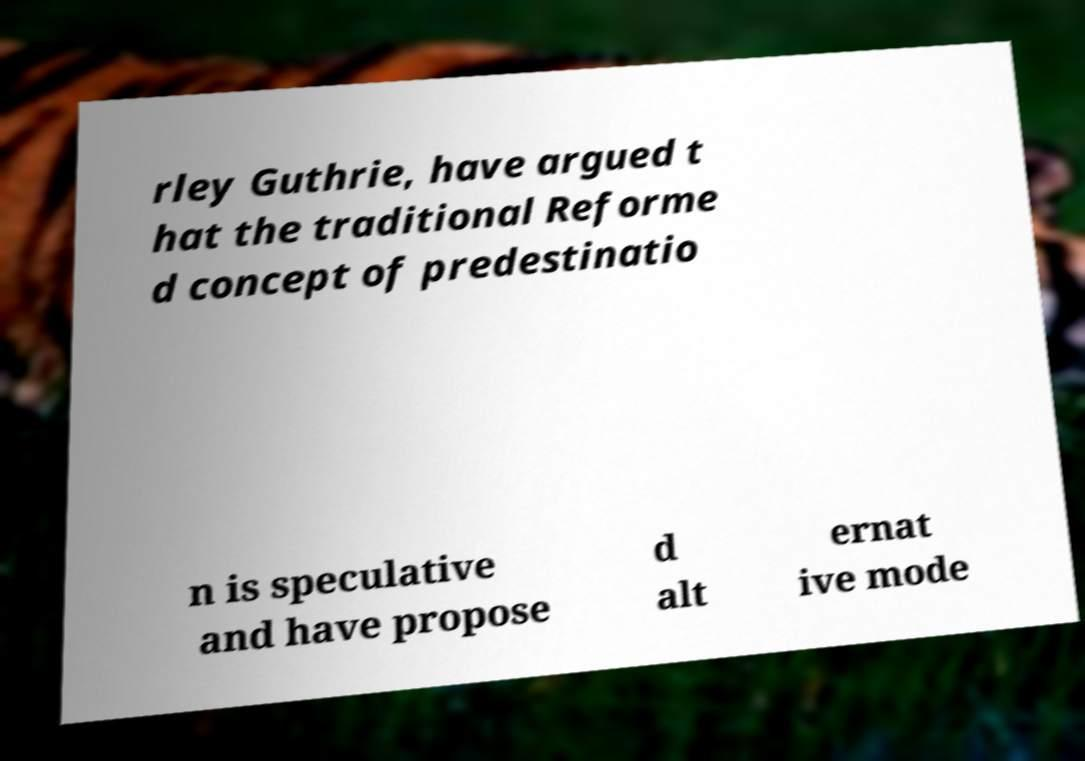There's text embedded in this image that I need extracted. Can you transcribe it verbatim? rley Guthrie, have argued t hat the traditional Reforme d concept of predestinatio n is speculative and have propose d alt ernat ive mode 